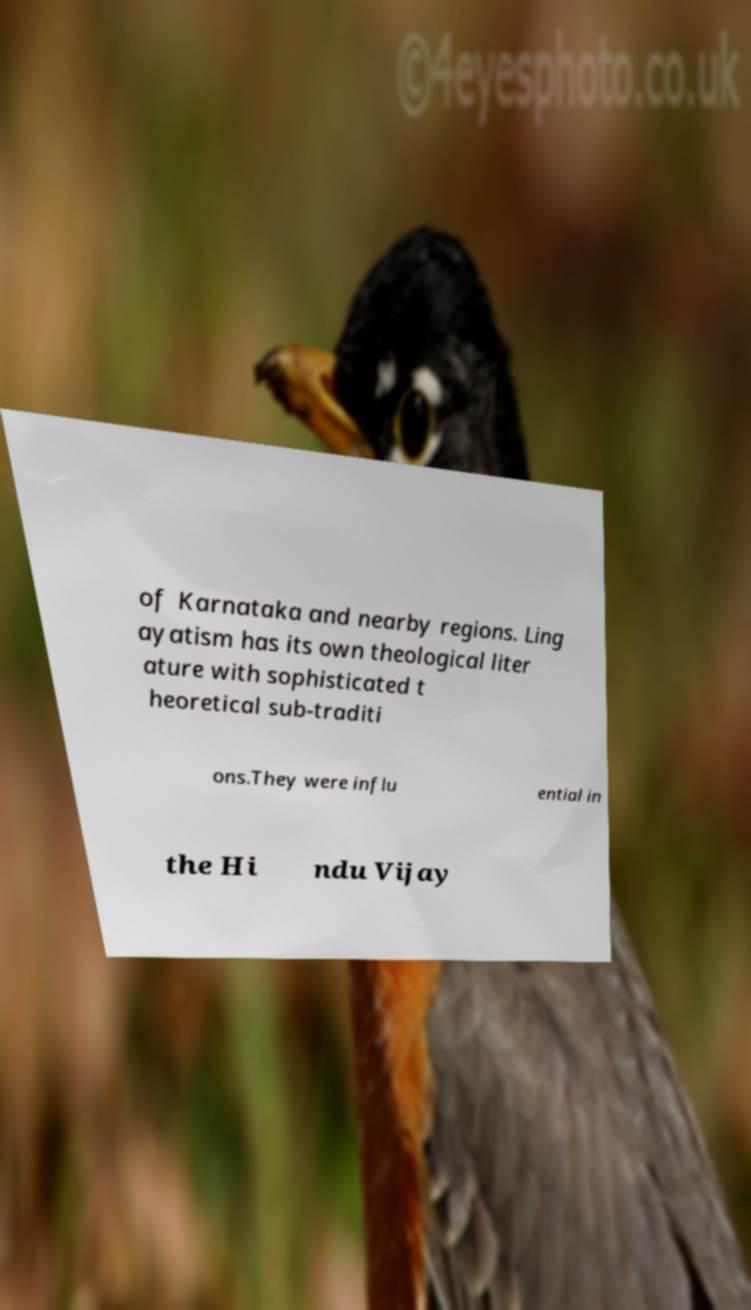Could you assist in decoding the text presented in this image and type it out clearly? of Karnataka and nearby regions. Ling ayatism has its own theological liter ature with sophisticated t heoretical sub-traditi ons.They were influ ential in the Hi ndu Vijay 